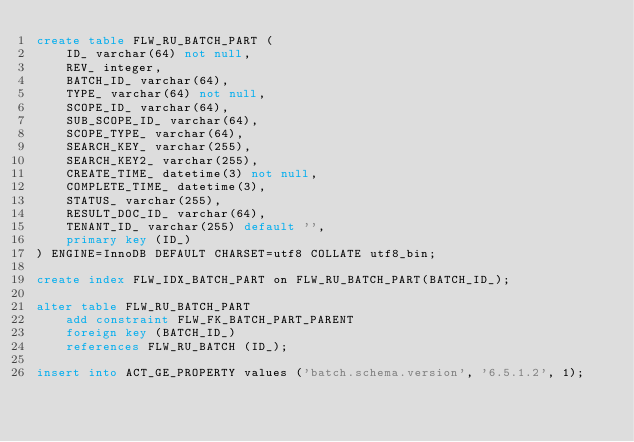Convert code to text. <code><loc_0><loc_0><loc_500><loc_500><_SQL_>create table FLW_RU_BATCH_PART (
    ID_ varchar(64) not null,
    REV_ integer,
    BATCH_ID_ varchar(64),
    TYPE_ varchar(64) not null,
    SCOPE_ID_ varchar(64),
    SUB_SCOPE_ID_ varchar(64),
    SCOPE_TYPE_ varchar(64),
    SEARCH_KEY_ varchar(255),
    SEARCH_KEY2_ varchar(255),
    CREATE_TIME_ datetime(3) not null,
    COMPLETE_TIME_ datetime(3),
    STATUS_ varchar(255),
    RESULT_DOC_ID_ varchar(64),
    TENANT_ID_ varchar(255) default '',
    primary key (ID_)
) ENGINE=InnoDB DEFAULT CHARSET=utf8 COLLATE utf8_bin;

create index FLW_IDX_BATCH_PART on FLW_RU_BATCH_PART(BATCH_ID_);

alter table FLW_RU_BATCH_PART
    add constraint FLW_FK_BATCH_PART_PARENT
    foreign key (BATCH_ID_)
    references FLW_RU_BATCH (ID_);

insert into ACT_GE_PROPERTY values ('batch.schema.version', '6.5.1.2', 1);
</code> 